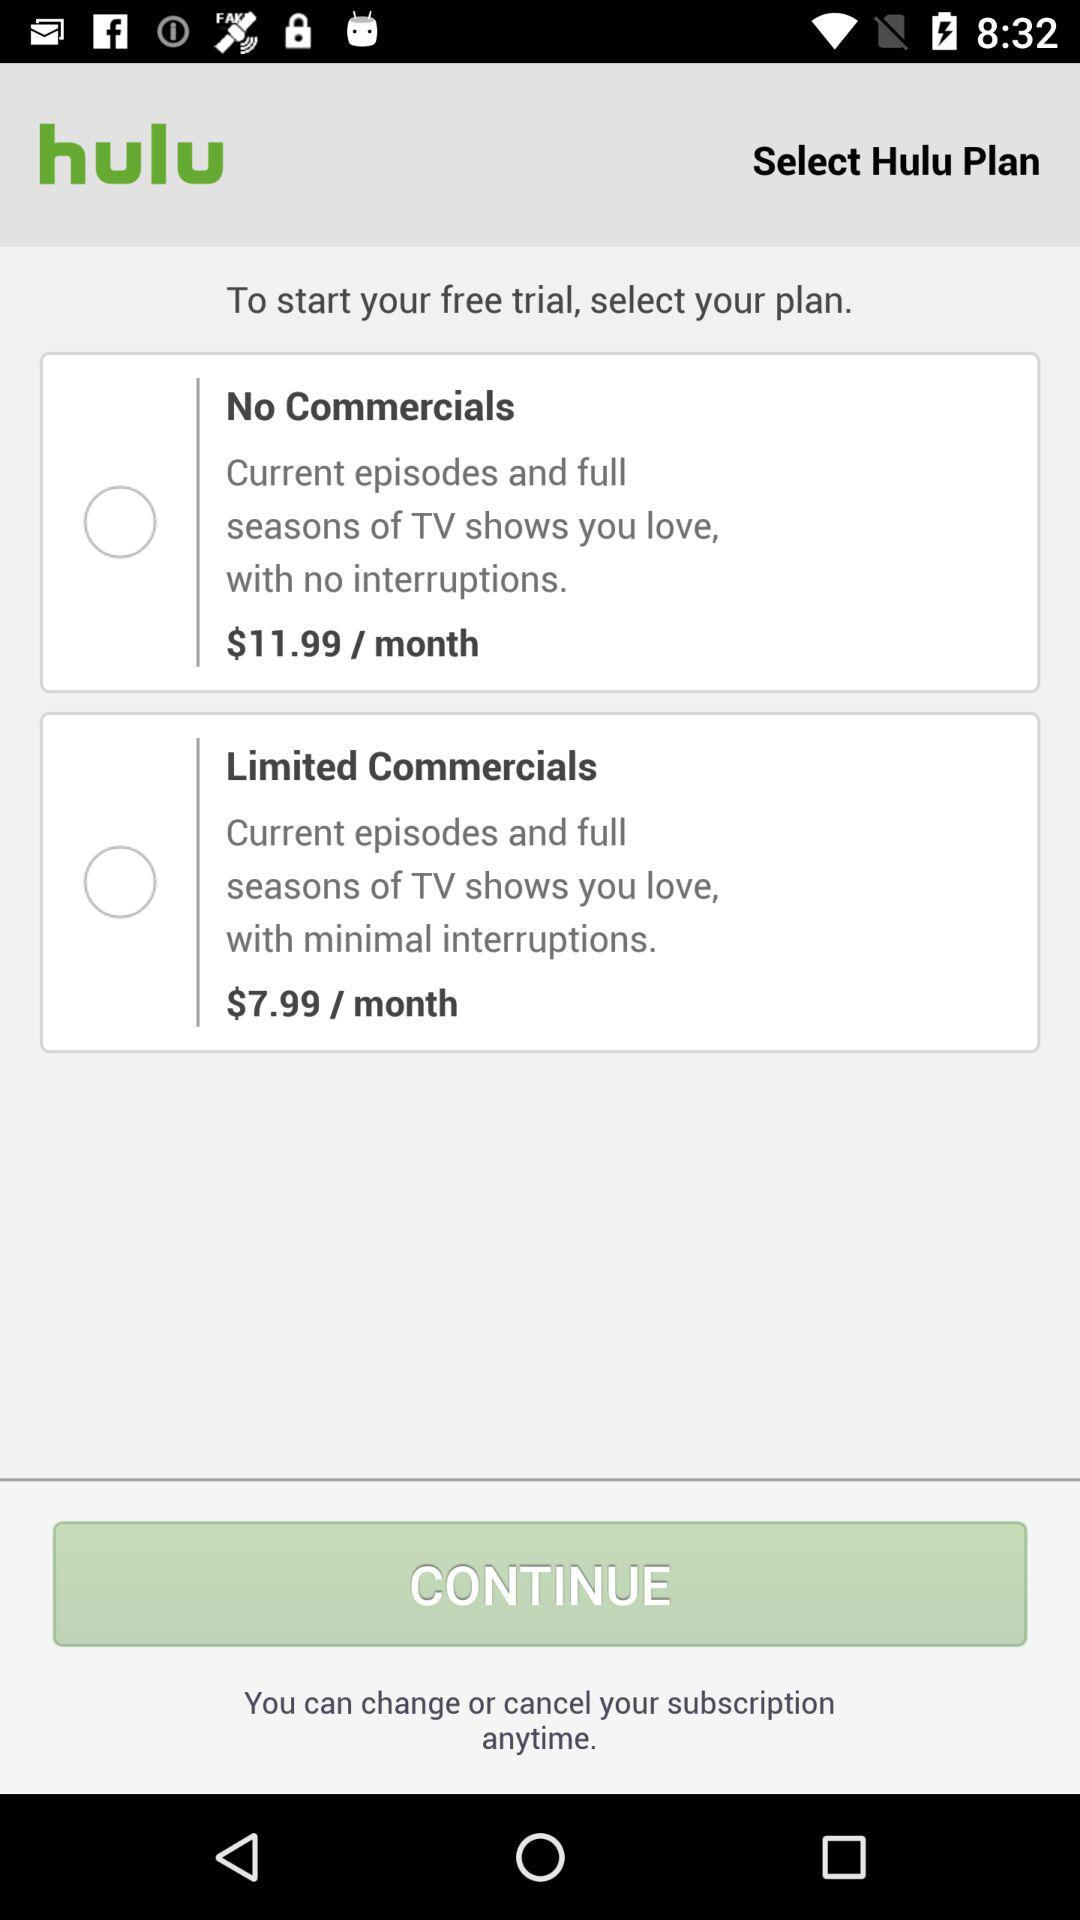What is the app name? The app name is "hulu". 